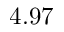<formula> <loc_0><loc_0><loc_500><loc_500>4 . 9 7</formula> 